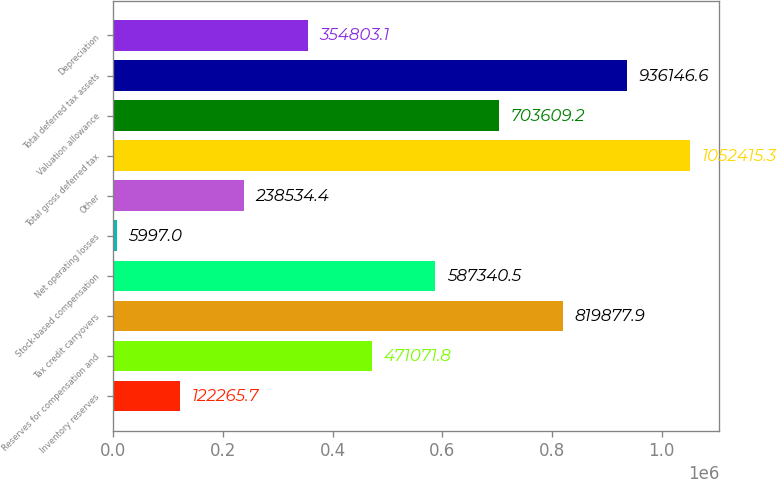Convert chart. <chart><loc_0><loc_0><loc_500><loc_500><bar_chart><fcel>Inventory reserves<fcel>Reserves for compensation and<fcel>Tax credit carryovers<fcel>Stock-based compensation<fcel>Net operating losses<fcel>Other<fcel>Total gross deferred tax<fcel>Valuation allowance<fcel>Total deferred tax assets<fcel>Depreciation<nl><fcel>122266<fcel>471072<fcel>819878<fcel>587340<fcel>5997<fcel>238534<fcel>1.05242e+06<fcel>703609<fcel>936147<fcel>354803<nl></chart> 